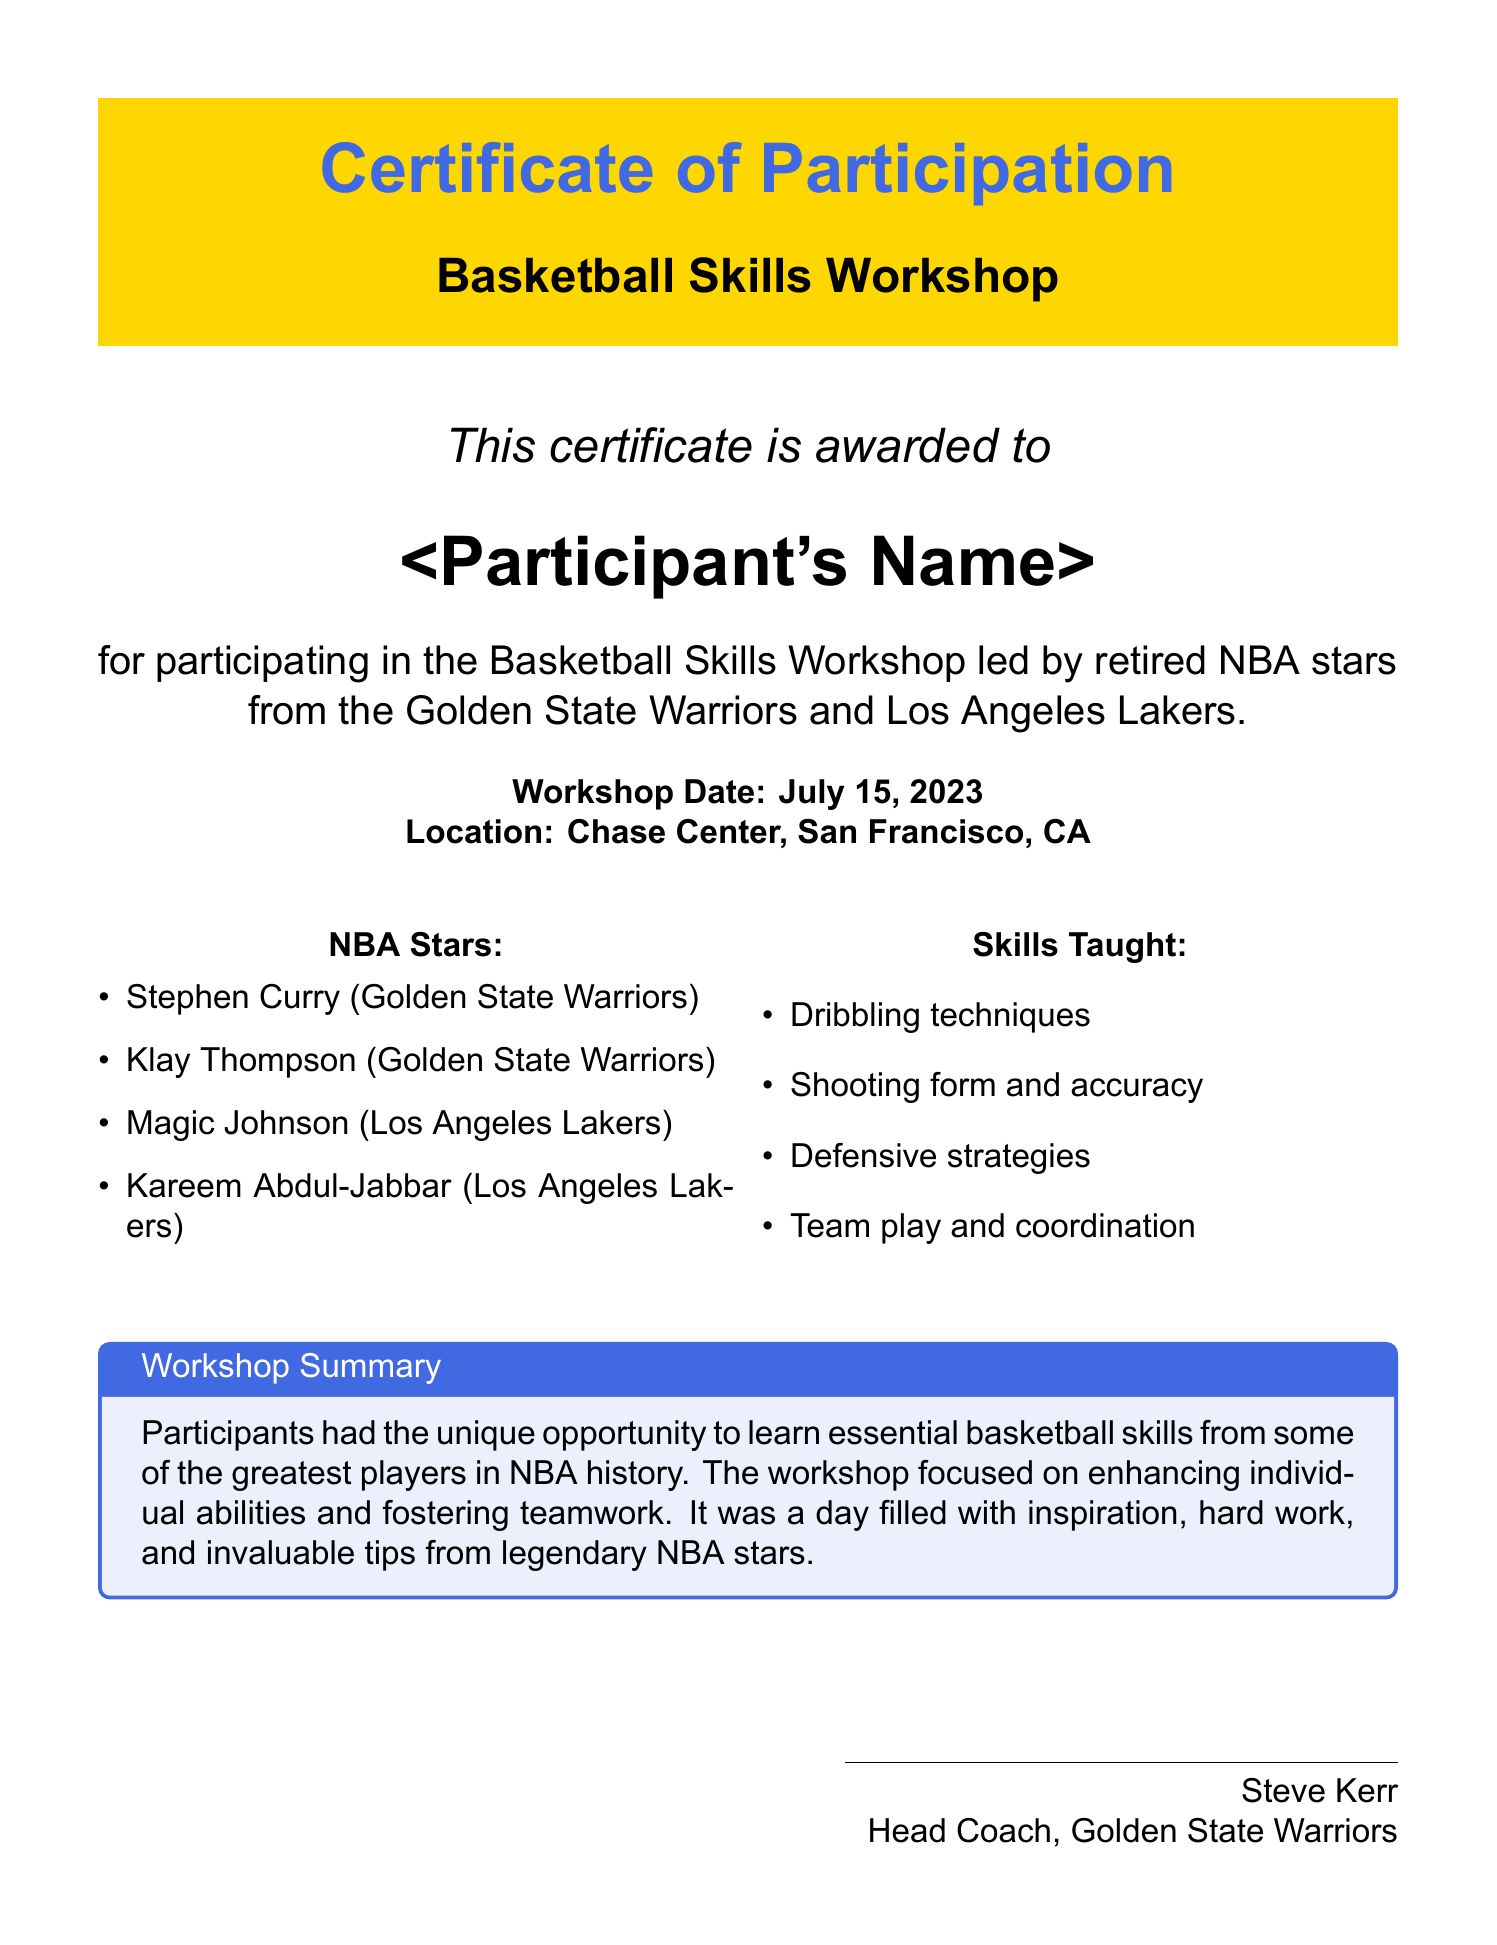What is the title of the document? The title of the document is prominently displayed at the top and is "Certificate of Participation."
Answer: Certificate of Participation Who is the certificate awarded to? The recipient's name is meant to be filled in and is indicated as "<Participant's Name>."
Answer: <Participant's Name> What is the workshop date? The document provides the specific date when the workshop took place, which is listed clearly.
Answer: July 15, 2023 Where did the workshop take place? The location of the workshop is explicitly mentioned in the document.
Answer: Chase Center, San Francisco, CA Which NBA star is from the Golden State Warriors? Participants in the workshop included notable players from the Golden State Warriors.
Answer: Stephen Curry Name one skill taught in the workshop. A list of skills covered in the workshop is provided, and one of these skills is being requested.
Answer: Dribbling techniques Who is the head coach mentioned in the certificate? The document lists the name of the person endorsing the certificate as the head coach of the Golden State Warriors.
Answer: Steve Kerr What is the main focus of the workshop? A summary within the document outlines the purpose of the workshop.
Answer: Enhancing individual abilities and fostering teamwork How many NBA stars are listed in the document? The document explicitly lists the NBA stars who led the workshop.
Answer: Four 